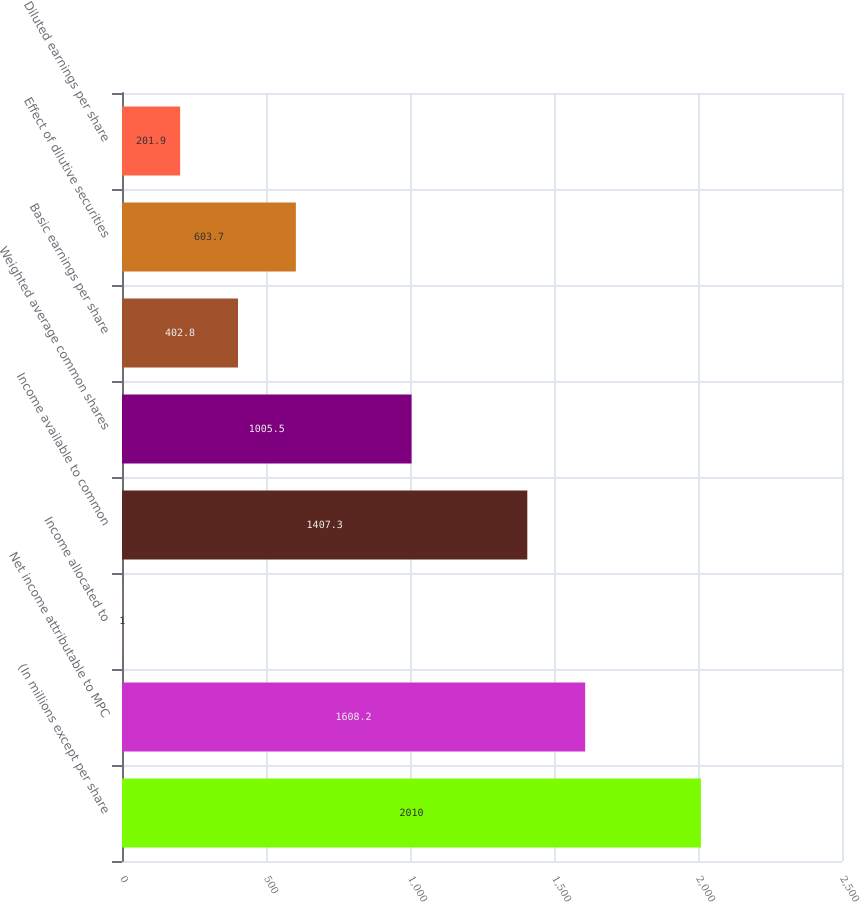Convert chart to OTSL. <chart><loc_0><loc_0><loc_500><loc_500><bar_chart><fcel>(In millions except per share<fcel>Net income attributable to MPC<fcel>Income allocated to<fcel>Income available to common<fcel>Weighted average common shares<fcel>Basic earnings per share<fcel>Effect of dilutive securities<fcel>Diluted earnings per share<nl><fcel>2010<fcel>1608.2<fcel>1<fcel>1407.3<fcel>1005.5<fcel>402.8<fcel>603.7<fcel>201.9<nl></chart> 